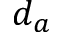<formula> <loc_0><loc_0><loc_500><loc_500>d _ { a }</formula> 